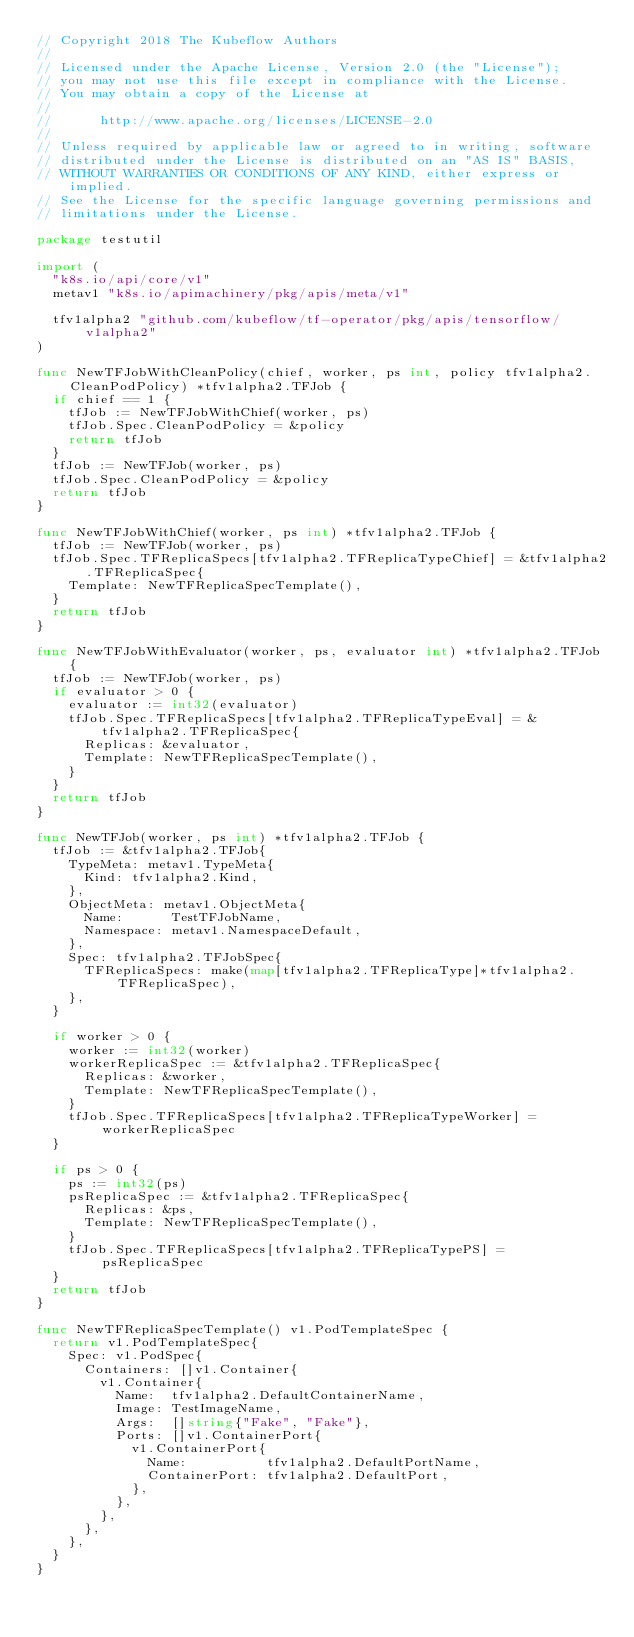Convert code to text. <code><loc_0><loc_0><loc_500><loc_500><_Go_>// Copyright 2018 The Kubeflow Authors
//
// Licensed under the Apache License, Version 2.0 (the "License");
// you may not use this file except in compliance with the License.
// You may obtain a copy of the License at
//
//      http://www.apache.org/licenses/LICENSE-2.0
//
// Unless required by applicable law or agreed to in writing, software
// distributed under the License is distributed on an "AS IS" BASIS,
// WITHOUT WARRANTIES OR CONDITIONS OF ANY KIND, either express or implied.
// See the License for the specific language governing permissions and
// limitations under the License.

package testutil

import (
	"k8s.io/api/core/v1"
	metav1 "k8s.io/apimachinery/pkg/apis/meta/v1"

	tfv1alpha2 "github.com/kubeflow/tf-operator/pkg/apis/tensorflow/v1alpha2"
)

func NewTFJobWithCleanPolicy(chief, worker, ps int, policy tfv1alpha2.CleanPodPolicy) *tfv1alpha2.TFJob {
	if chief == 1 {
		tfJob := NewTFJobWithChief(worker, ps)
		tfJob.Spec.CleanPodPolicy = &policy
		return tfJob
	}
	tfJob := NewTFJob(worker, ps)
	tfJob.Spec.CleanPodPolicy = &policy
	return tfJob
}

func NewTFJobWithChief(worker, ps int) *tfv1alpha2.TFJob {
	tfJob := NewTFJob(worker, ps)
	tfJob.Spec.TFReplicaSpecs[tfv1alpha2.TFReplicaTypeChief] = &tfv1alpha2.TFReplicaSpec{
		Template: NewTFReplicaSpecTemplate(),
	}
	return tfJob
}

func NewTFJobWithEvaluator(worker, ps, evaluator int) *tfv1alpha2.TFJob {
	tfJob := NewTFJob(worker, ps)
	if evaluator > 0 {
		evaluator := int32(evaluator)
		tfJob.Spec.TFReplicaSpecs[tfv1alpha2.TFReplicaTypeEval] = &tfv1alpha2.TFReplicaSpec{
			Replicas: &evaluator,
			Template: NewTFReplicaSpecTemplate(),
		}
	}
	return tfJob
}

func NewTFJob(worker, ps int) *tfv1alpha2.TFJob {
	tfJob := &tfv1alpha2.TFJob{
		TypeMeta: metav1.TypeMeta{
			Kind: tfv1alpha2.Kind,
		},
		ObjectMeta: metav1.ObjectMeta{
			Name:      TestTFJobName,
			Namespace: metav1.NamespaceDefault,
		},
		Spec: tfv1alpha2.TFJobSpec{
			TFReplicaSpecs: make(map[tfv1alpha2.TFReplicaType]*tfv1alpha2.TFReplicaSpec),
		},
	}

	if worker > 0 {
		worker := int32(worker)
		workerReplicaSpec := &tfv1alpha2.TFReplicaSpec{
			Replicas: &worker,
			Template: NewTFReplicaSpecTemplate(),
		}
		tfJob.Spec.TFReplicaSpecs[tfv1alpha2.TFReplicaTypeWorker] = workerReplicaSpec
	}

	if ps > 0 {
		ps := int32(ps)
		psReplicaSpec := &tfv1alpha2.TFReplicaSpec{
			Replicas: &ps,
			Template: NewTFReplicaSpecTemplate(),
		}
		tfJob.Spec.TFReplicaSpecs[tfv1alpha2.TFReplicaTypePS] = psReplicaSpec
	}
	return tfJob
}

func NewTFReplicaSpecTemplate() v1.PodTemplateSpec {
	return v1.PodTemplateSpec{
		Spec: v1.PodSpec{
			Containers: []v1.Container{
				v1.Container{
					Name:  tfv1alpha2.DefaultContainerName,
					Image: TestImageName,
					Args:  []string{"Fake", "Fake"},
					Ports: []v1.ContainerPort{
						v1.ContainerPort{
							Name:          tfv1alpha2.DefaultPortName,
							ContainerPort: tfv1alpha2.DefaultPort,
						},
					},
				},
			},
		},
	}
}
</code> 